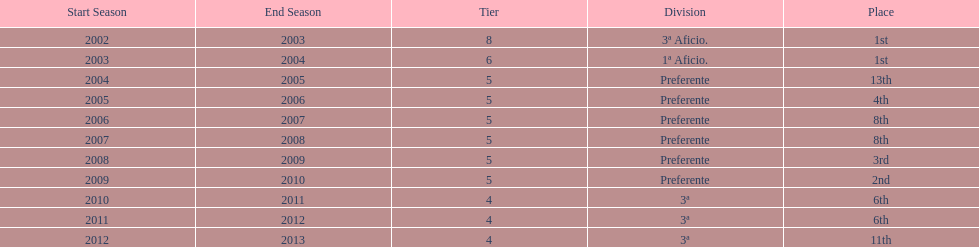Help me parse the entirety of this table. {'header': ['Start Season', 'End Season', 'Tier', 'Division', 'Place'], 'rows': [['2002', '2003', '8', '3ª Aficio.', '1st'], ['2003', '2004', '6', '1ª Aficio.', '1st'], ['2004', '2005', '5', 'Preferente', '13th'], ['2005', '2006', '5', 'Preferente', '4th'], ['2006', '2007', '5', 'Preferente', '8th'], ['2007', '2008', '5', 'Preferente', '8th'], ['2008', '2009', '5', 'Preferente', '3rd'], ['2009', '2010', '5', 'Preferente', '2nd'], ['2010', '2011', '4', '3ª', '6th'], ['2011', '2012', '4', '3ª', '6th'], ['2012', '2013', '4', '3ª', '11th']]} How long did the team stay in first place? 2 years. 